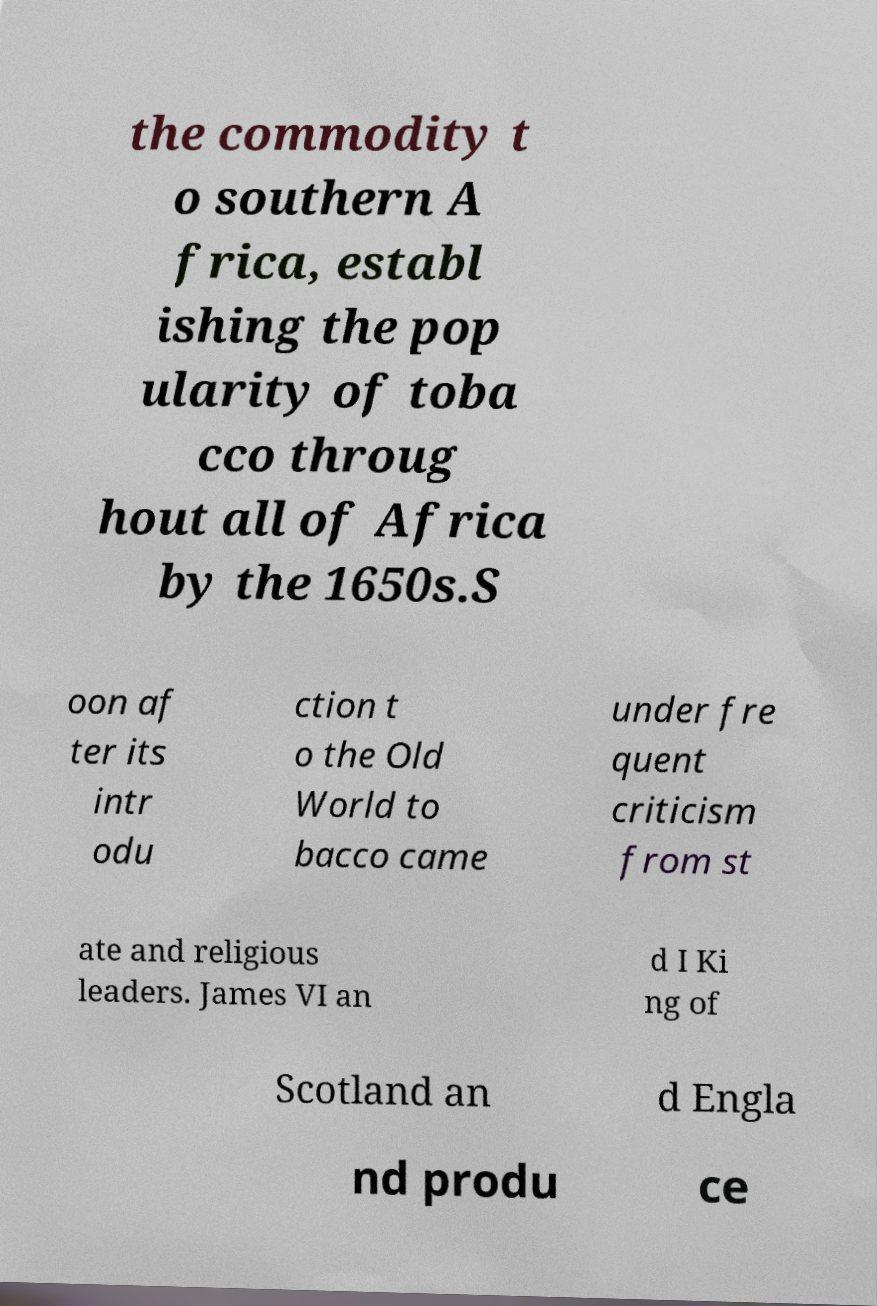What messages or text are displayed in this image? I need them in a readable, typed format. the commodity t o southern A frica, establ ishing the pop ularity of toba cco throug hout all of Africa by the 1650s.S oon af ter its intr odu ction t o the Old World to bacco came under fre quent criticism from st ate and religious leaders. James VI an d I Ki ng of Scotland an d Engla nd produ ce 